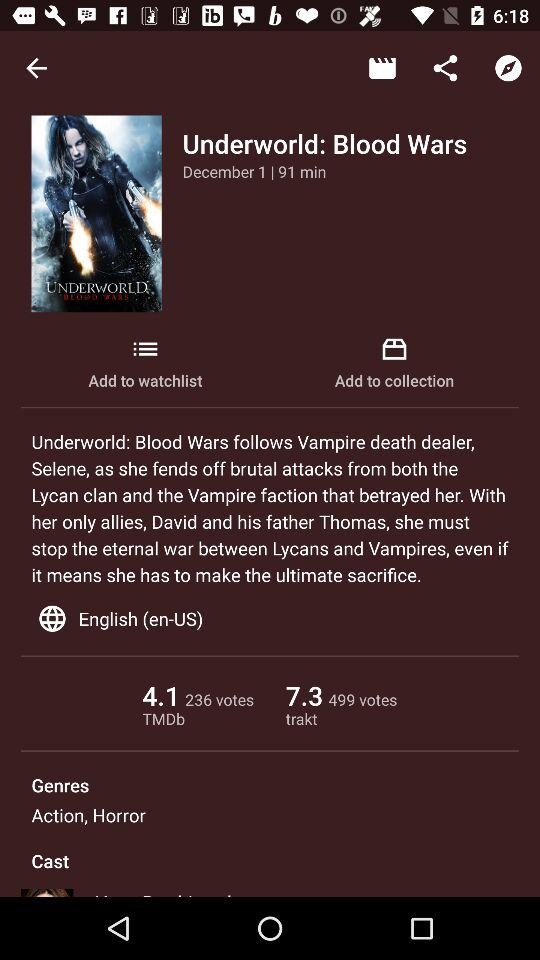What is the title of the movie? The title of the movie is "Underworld: Blood Wars". 